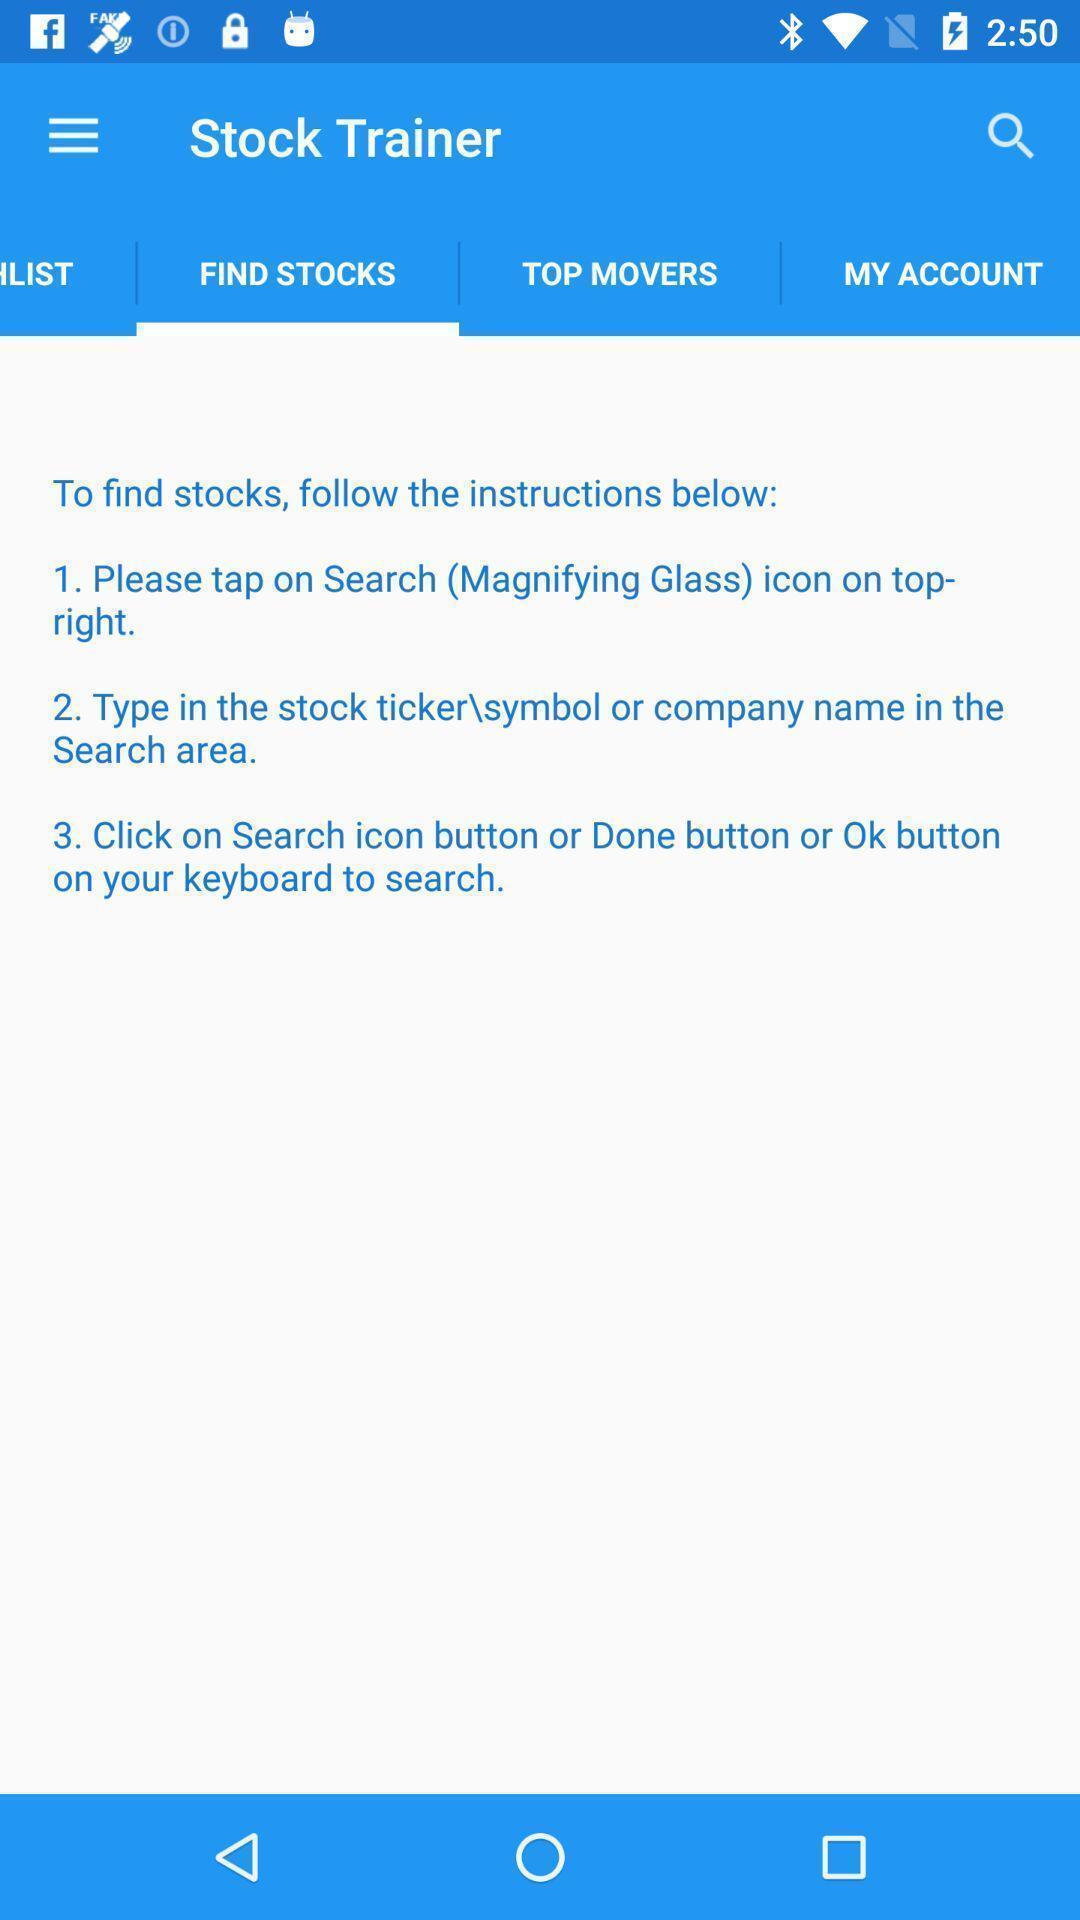Provide a detailed account of this screenshot. Page showing the guidelines find stocks. 